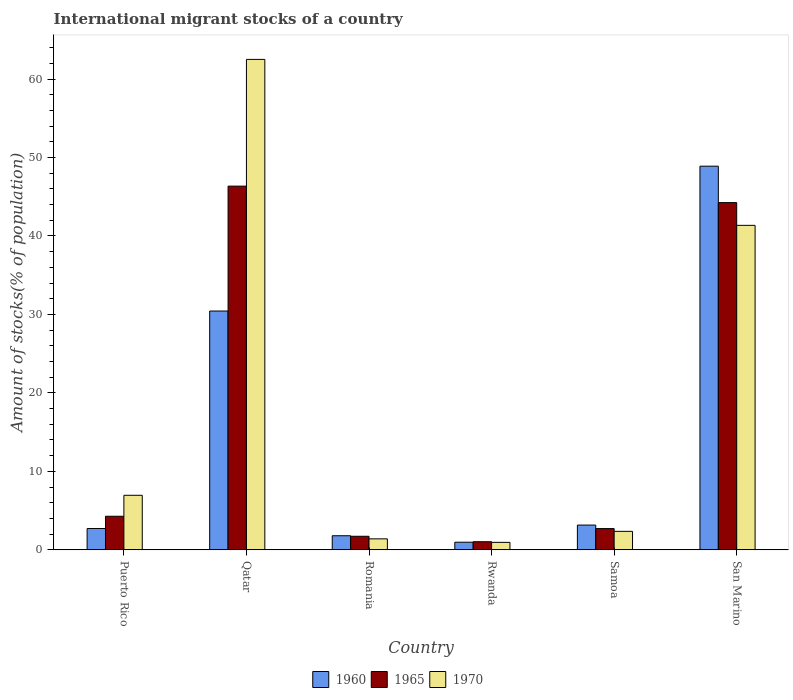How many different coloured bars are there?
Offer a very short reply. 3. Are the number of bars per tick equal to the number of legend labels?
Your response must be concise. Yes. How many bars are there on the 2nd tick from the right?
Your answer should be very brief. 3. What is the label of the 2nd group of bars from the left?
Provide a succinct answer. Qatar. In how many cases, is the number of bars for a given country not equal to the number of legend labels?
Offer a very short reply. 0. What is the amount of stocks in in 1965 in San Marino?
Your answer should be compact. 44.25. Across all countries, what is the maximum amount of stocks in in 1970?
Provide a succinct answer. 62.51. Across all countries, what is the minimum amount of stocks in in 1965?
Give a very brief answer. 1.03. In which country was the amount of stocks in in 1960 maximum?
Your answer should be compact. San Marino. In which country was the amount of stocks in in 1965 minimum?
Offer a very short reply. Rwanda. What is the total amount of stocks in in 1965 in the graph?
Ensure brevity in your answer.  100.36. What is the difference between the amount of stocks in in 1970 in Samoa and that in San Marino?
Keep it short and to the point. -39. What is the difference between the amount of stocks in in 1965 in Puerto Rico and the amount of stocks in in 1960 in Rwanda?
Your answer should be very brief. 3.31. What is the average amount of stocks in in 1965 per country?
Make the answer very short. 16.73. What is the difference between the amount of stocks in of/in 1960 and amount of stocks in of/in 1970 in Puerto Rico?
Your answer should be compact. -4.24. In how many countries, is the amount of stocks in in 1960 greater than 36 %?
Offer a terse response. 1. What is the ratio of the amount of stocks in in 1965 in Puerto Rico to that in Romania?
Give a very brief answer. 2.47. Is the difference between the amount of stocks in in 1960 in Rwanda and San Marino greater than the difference between the amount of stocks in in 1970 in Rwanda and San Marino?
Provide a short and direct response. No. What is the difference between the highest and the second highest amount of stocks in in 1970?
Your answer should be compact. -21.15. What is the difference between the highest and the lowest amount of stocks in in 1960?
Provide a short and direct response. 47.93. In how many countries, is the amount of stocks in in 1965 greater than the average amount of stocks in in 1965 taken over all countries?
Make the answer very short. 2. Is the sum of the amount of stocks in in 1965 in Puerto Rico and Samoa greater than the maximum amount of stocks in in 1970 across all countries?
Offer a terse response. No. Is it the case that in every country, the sum of the amount of stocks in in 1965 and amount of stocks in in 1960 is greater than the amount of stocks in in 1970?
Offer a terse response. Yes. Are all the bars in the graph horizontal?
Provide a succinct answer. No. Does the graph contain any zero values?
Offer a very short reply. No. Does the graph contain grids?
Keep it short and to the point. No. What is the title of the graph?
Make the answer very short. International migrant stocks of a country. Does "2002" appear as one of the legend labels in the graph?
Make the answer very short. No. What is the label or title of the Y-axis?
Give a very brief answer. Amount of stocks(% of population). What is the Amount of stocks(% of population) of 1960 in Puerto Rico?
Your response must be concise. 2.72. What is the Amount of stocks(% of population) in 1965 in Puerto Rico?
Your answer should be very brief. 4.28. What is the Amount of stocks(% of population) in 1970 in Puerto Rico?
Make the answer very short. 6.95. What is the Amount of stocks(% of population) in 1960 in Qatar?
Your response must be concise. 30.44. What is the Amount of stocks(% of population) of 1965 in Qatar?
Offer a very short reply. 46.36. What is the Amount of stocks(% of population) in 1970 in Qatar?
Offer a terse response. 62.51. What is the Amount of stocks(% of population) of 1960 in Romania?
Ensure brevity in your answer.  1.8. What is the Amount of stocks(% of population) of 1965 in Romania?
Your answer should be compact. 1.73. What is the Amount of stocks(% of population) in 1970 in Romania?
Make the answer very short. 1.4. What is the Amount of stocks(% of population) in 1960 in Rwanda?
Offer a terse response. 0.97. What is the Amount of stocks(% of population) of 1965 in Rwanda?
Your answer should be compact. 1.03. What is the Amount of stocks(% of population) in 1970 in Rwanda?
Offer a very short reply. 0.95. What is the Amount of stocks(% of population) of 1960 in Samoa?
Your answer should be compact. 3.16. What is the Amount of stocks(% of population) of 1965 in Samoa?
Provide a succinct answer. 2.71. What is the Amount of stocks(% of population) in 1970 in Samoa?
Offer a terse response. 2.36. What is the Amount of stocks(% of population) in 1960 in San Marino?
Keep it short and to the point. 48.9. What is the Amount of stocks(% of population) in 1965 in San Marino?
Provide a succinct answer. 44.25. What is the Amount of stocks(% of population) in 1970 in San Marino?
Provide a short and direct response. 41.36. Across all countries, what is the maximum Amount of stocks(% of population) of 1960?
Provide a succinct answer. 48.9. Across all countries, what is the maximum Amount of stocks(% of population) of 1965?
Make the answer very short. 46.36. Across all countries, what is the maximum Amount of stocks(% of population) of 1970?
Provide a short and direct response. 62.51. Across all countries, what is the minimum Amount of stocks(% of population) of 1960?
Make the answer very short. 0.97. Across all countries, what is the minimum Amount of stocks(% of population) in 1965?
Your answer should be very brief. 1.03. Across all countries, what is the minimum Amount of stocks(% of population) in 1970?
Offer a very short reply. 0.95. What is the total Amount of stocks(% of population) of 1960 in the graph?
Your response must be concise. 87.98. What is the total Amount of stocks(% of population) in 1965 in the graph?
Keep it short and to the point. 100.36. What is the total Amount of stocks(% of population) in 1970 in the graph?
Your answer should be very brief. 115.53. What is the difference between the Amount of stocks(% of population) of 1960 in Puerto Rico and that in Qatar?
Make the answer very short. -27.72. What is the difference between the Amount of stocks(% of population) in 1965 in Puerto Rico and that in Qatar?
Offer a terse response. -42.07. What is the difference between the Amount of stocks(% of population) of 1970 in Puerto Rico and that in Qatar?
Offer a terse response. -55.56. What is the difference between the Amount of stocks(% of population) in 1960 in Puerto Rico and that in Romania?
Offer a terse response. 0.92. What is the difference between the Amount of stocks(% of population) in 1965 in Puerto Rico and that in Romania?
Your answer should be compact. 2.55. What is the difference between the Amount of stocks(% of population) of 1970 in Puerto Rico and that in Romania?
Ensure brevity in your answer.  5.55. What is the difference between the Amount of stocks(% of population) in 1960 in Puerto Rico and that in Rwanda?
Your answer should be compact. 1.74. What is the difference between the Amount of stocks(% of population) of 1965 in Puerto Rico and that in Rwanda?
Give a very brief answer. 3.25. What is the difference between the Amount of stocks(% of population) in 1970 in Puerto Rico and that in Rwanda?
Offer a terse response. 6. What is the difference between the Amount of stocks(% of population) of 1960 in Puerto Rico and that in Samoa?
Keep it short and to the point. -0.44. What is the difference between the Amount of stocks(% of population) in 1965 in Puerto Rico and that in Samoa?
Offer a very short reply. 1.57. What is the difference between the Amount of stocks(% of population) in 1970 in Puerto Rico and that in Samoa?
Your answer should be very brief. 4.6. What is the difference between the Amount of stocks(% of population) in 1960 in Puerto Rico and that in San Marino?
Provide a short and direct response. -46.18. What is the difference between the Amount of stocks(% of population) in 1965 in Puerto Rico and that in San Marino?
Your response must be concise. -39.97. What is the difference between the Amount of stocks(% of population) in 1970 in Puerto Rico and that in San Marino?
Your response must be concise. -34.4. What is the difference between the Amount of stocks(% of population) of 1960 in Qatar and that in Romania?
Provide a short and direct response. 28.64. What is the difference between the Amount of stocks(% of population) of 1965 in Qatar and that in Romania?
Ensure brevity in your answer.  44.63. What is the difference between the Amount of stocks(% of population) in 1970 in Qatar and that in Romania?
Make the answer very short. 61.11. What is the difference between the Amount of stocks(% of population) of 1960 in Qatar and that in Rwanda?
Offer a very short reply. 29.47. What is the difference between the Amount of stocks(% of population) of 1965 in Qatar and that in Rwanda?
Ensure brevity in your answer.  45.32. What is the difference between the Amount of stocks(% of population) of 1970 in Qatar and that in Rwanda?
Provide a short and direct response. 61.56. What is the difference between the Amount of stocks(% of population) in 1960 in Qatar and that in Samoa?
Ensure brevity in your answer.  27.28. What is the difference between the Amount of stocks(% of population) of 1965 in Qatar and that in Samoa?
Ensure brevity in your answer.  43.65. What is the difference between the Amount of stocks(% of population) of 1970 in Qatar and that in Samoa?
Offer a very short reply. 60.15. What is the difference between the Amount of stocks(% of population) in 1960 in Qatar and that in San Marino?
Give a very brief answer. -18.46. What is the difference between the Amount of stocks(% of population) of 1965 in Qatar and that in San Marino?
Give a very brief answer. 2.1. What is the difference between the Amount of stocks(% of population) in 1970 in Qatar and that in San Marino?
Give a very brief answer. 21.15. What is the difference between the Amount of stocks(% of population) in 1960 in Romania and that in Rwanda?
Ensure brevity in your answer.  0.82. What is the difference between the Amount of stocks(% of population) of 1965 in Romania and that in Rwanda?
Keep it short and to the point. 0.7. What is the difference between the Amount of stocks(% of population) in 1970 in Romania and that in Rwanda?
Provide a short and direct response. 0.45. What is the difference between the Amount of stocks(% of population) of 1960 in Romania and that in Samoa?
Keep it short and to the point. -1.36. What is the difference between the Amount of stocks(% of population) of 1965 in Romania and that in Samoa?
Keep it short and to the point. -0.98. What is the difference between the Amount of stocks(% of population) in 1970 in Romania and that in Samoa?
Offer a terse response. -0.95. What is the difference between the Amount of stocks(% of population) of 1960 in Romania and that in San Marino?
Offer a terse response. -47.1. What is the difference between the Amount of stocks(% of population) in 1965 in Romania and that in San Marino?
Keep it short and to the point. -42.52. What is the difference between the Amount of stocks(% of population) in 1970 in Romania and that in San Marino?
Keep it short and to the point. -39.95. What is the difference between the Amount of stocks(% of population) of 1960 in Rwanda and that in Samoa?
Give a very brief answer. -2.18. What is the difference between the Amount of stocks(% of population) of 1965 in Rwanda and that in Samoa?
Your answer should be very brief. -1.67. What is the difference between the Amount of stocks(% of population) in 1970 in Rwanda and that in Samoa?
Ensure brevity in your answer.  -1.4. What is the difference between the Amount of stocks(% of population) in 1960 in Rwanda and that in San Marino?
Your answer should be compact. -47.93. What is the difference between the Amount of stocks(% of population) of 1965 in Rwanda and that in San Marino?
Give a very brief answer. -43.22. What is the difference between the Amount of stocks(% of population) in 1970 in Rwanda and that in San Marino?
Provide a succinct answer. -40.4. What is the difference between the Amount of stocks(% of population) in 1960 in Samoa and that in San Marino?
Your answer should be very brief. -45.74. What is the difference between the Amount of stocks(% of population) of 1965 in Samoa and that in San Marino?
Your answer should be compact. -41.55. What is the difference between the Amount of stocks(% of population) of 1970 in Samoa and that in San Marino?
Ensure brevity in your answer.  -39. What is the difference between the Amount of stocks(% of population) of 1960 in Puerto Rico and the Amount of stocks(% of population) of 1965 in Qatar?
Offer a terse response. -43.64. What is the difference between the Amount of stocks(% of population) of 1960 in Puerto Rico and the Amount of stocks(% of population) of 1970 in Qatar?
Give a very brief answer. -59.79. What is the difference between the Amount of stocks(% of population) in 1965 in Puerto Rico and the Amount of stocks(% of population) in 1970 in Qatar?
Give a very brief answer. -58.23. What is the difference between the Amount of stocks(% of population) of 1960 in Puerto Rico and the Amount of stocks(% of population) of 1965 in Romania?
Your answer should be very brief. 0.99. What is the difference between the Amount of stocks(% of population) in 1960 in Puerto Rico and the Amount of stocks(% of population) in 1970 in Romania?
Your response must be concise. 1.32. What is the difference between the Amount of stocks(% of population) of 1965 in Puerto Rico and the Amount of stocks(% of population) of 1970 in Romania?
Offer a very short reply. 2.88. What is the difference between the Amount of stocks(% of population) of 1960 in Puerto Rico and the Amount of stocks(% of population) of 1965 in Rwanda?
Offer a very short reply. 1.68. What is the difference between the Amount of stocks(% of population) in 1960 in Puerto Rico and the Amount of stocks(% of population) in 1970 in Rwanda?
Your answer should be very brief. 1.76. What is the difference between the Amount of stocks(% of population) of 1965 in Puerto Rico and the Amount of stocks(% of population) of 1970 in Rwanda?
Offer a very short reply. 3.33. What is the difference between the Amount of stocks(% of population) in 1960 in Puerto Rico and the Amount of stocks(% of population) in 1965 in Samoa?
Provide a succinct answer. 0.01. What is the difference between the Amount of stocks(% of population) in 1960 in Puerto Rico and the Amount of stocks(% of population) in 1970 in Samoa?
Offer a very short reply. 0.36. What is the difference between the Amount of stocks(% of population) of 1965 in Puerto Rico and the Amount of stocks(% of population) of 1970 in Samoa?
Give a very brief answer. 1.92. What is the difference between the Amount of stocks(% of population) of 1960 in Puerto Rico and the Amount of stocks(% of population) of 1965 in San Marino?
Keep it short and to the point. -41.54. What is the difference between the Amount of stocks(% of population) of 1960 in Puerto Rico and the Amount of stocks(% of population) of 1970 in San Marino?
Offer a very short reply. -38.64. What is the difference between the Amount of stocks(% of population) of 1965 in Puerto Rico and the Amount of stocks(% of population) of 1970 in San Marino?
Offer a very short reply. -37.08. What is the difference between the Amount of stocks(% of population) of 1960 in Qatar and the Amount of stocks(% of population) of 1965 in Romania?
Make the answer very short. 28.71. What is the difference between the Amount of stocks(% of population) of 1960 in Qatar and the Amount of stocks(% of population) of 1970 in Romania?
Offer a very short reply. 29.04. What is the difference between the Amount of stocks(% of population) of 1965 in Qatar and the Amount of stocks(% of population) of 1970 in Romania?
Provide a short and direct response. 44.95. What is the difference between the Amount of stocks(% of population) in 1960 in Qatar and the Amount of stocks(% of population) in 1965 in Rwanda?
Make the answer very short. 29.4. What is the difference between the Amount of stocks(% of population) of 1960 in Qatar and the Amount of stocks(% of population) of 1970 in Rwanda?
Give a very brief answer. 29.49. What is the difference between the Amount of stocks(% of population) of 1965 in Qatar and the Amount of stocks(% of population) of 1970 in Rwanda?
Provide a succinct answer. 45.4. What is the difference between the Amount of stocks(% of population) of 1960 in Qatar and the Amount of stocks(% of population) of 1965 in Samoa?
Your answer should be very brief. 27.73. What is the difference between the Amount of stocks(% of population) in 1960 in Qatar and the Amount of stocks(% of population) in 1970 in Samoa?
Your answer should be compact. 28.08. What is the difference between the Amount of stocks(% of population) in 1965 in Qatar and the Amount of stocks(% of population) in 1970 in Samoa?
Your answer should be compact. 44. What is the difference between the Amount of stocks(% of population) in 1960 in Qatar and the Amount of stocks(% of population) in 1965 in San Marino?
Ensure brevity in your answer.  -13.82. What is the difference between the Amount of stocks(% of population) in 1960 in Qatar and the Amount of stocks(% of population) in 1970 in San Marino?
Keep it short and to the point. -10.92. What is the difference between the Amount of stocks(% of population) of 1965 in Qatar and the Amount of stocks(% of population) of 1970 in San Marino?
Make the answer very short. 5. What is the difference between the Amount of stocks(% of population) in 1960 in Romania and the Amount of stocks(% of population) in 1965 in Rwanda?
Provide a short and direct response. 0.76. What is the difference between the Amount of stocks(% of population) of 1960 in Romania and the Amount of stocks(% of population) of 1970 in Rwanda?
Provide a succinct answer. 0.85. What is the difference between the Amount of stocks(% of population) in 1965 in Romania and the Amount of stocks(% of population) in 1970 in Rwanda?
Make the answer very short. 0.78. What is the difference between the Amount of stocks(% of population) in 1960 in Romania and the Amount of stocks(% of population) in 1965 in Samoa?
Your answer should be compact. -0.91. What is the difference between the Amount of stocks(% of population) of 1960 in Romania and the Amount of stocks(% of population) of 1970 in Samoa?
Ensure brevity in your answer.  -0.56. What is the difference between the Amount of stocks(% of population) in 1965 in Romania and the Amount of stocks(% of population) in 1970 in Samoa?
Ensure brevity in your answer.  -0.63. What is the difference between the Amount of stocks(% of population) in 1960 in Romania and the Amount of stocks(% of population) in 1965 in San Marino?
Offer a very short reply. -42.46. What is the difference between the Amount of stocks(% of population) in 1960 in Romania and the Amount of stocks(% of population) in 1970 in San Marino?
Keep it short and to the point. -39.56. What is the difference between the Amount of stocks(% of population) in 1965 in Romania and the Amount of stocks(% of population) in 1970 in San Marino?
Keep it short and to the point. -39.63. What is the difference between the Amount of stocks(% of population) in 1960 in Rwanda and the Amount of stocks(% of population) in 1965 in Samoa?
Your answer should be compact. -1.74. What is the difference between the Amount of stocks(% of population) of 1960 in Rwanda and the Amount of stocks(% of population) of 1970 in Samoa?
Provide a short and direct response. -1.38. What is the difference between the Amount of stocks(% of population) of 1965 in Rwanda and the Amount of stocks(% of population) of 1970 in Samoa?
Offer a very short reply. -1.32. What is the difference between the Amount of stocks(% of population) of 1960 in Rwanda and the Amount of stocks(% of population) of 1965 in San Marino?
Provide a succinct answer. -43.28. What is the difference between the Amount of stocks(% of population) of 1960 in Rwanda and the Amount of stocks(% of population) of 1970 in San Marino?
Your answer should be compact. -40.38. What is the difference between the Amount of stocks(% of population) in 1965 in Rwanda and the Amount of stocks(% of population) in 1970 in San Marino?
Keep it short and to the point. -40.32. What is the difference between the Amount of stocks(% of population) in 1960 in Samoa and the Amount of stocks(% of population) in 1965 in San Marino?
Provide a succinct answer. -41.1. What is the difference between the Amount of stocks(% of population) of 1960 in Samoa and the Amount of stocks(% of population) of 1970 in San Marino?
Offer a very short reply. -38.2. What is the difference between the Amount of stocks(% of population) in 1965 in Samoa and the Amount of stocks(% of population) in 1970 in San Marino?
Offer a terse response. -38.65. What is the average Amount of stocks(% of population) of 1960 per country?
Your answer should be very brief. 14.66. What is the average Amount of stocks(% of population) of 1965 per country?
Your response must be concise. 16.73. What is the average Amount of stocks(% of population) in 1970 per country?
Offer a very short reply. 19.25. What is the difference between the Amount of stocks(% of population) of 1960 and Amount of stocks(% of population) of 1965 in Puerto Rico?
Provide a succinct answer. -1.56. What is the difference between the Amount of stocks(% of population) in 1960 and Amount of stocks(% of population) in 1970 in Puerto Rico?
Make the answer very short. -4.24. What is the difference between the Amount of stocks(% of population) of 1965 and Amount of stocks(% of population) of 1970 in Puerto Rico?
Offer a terse response. -2.67. What is the difference between the Amount of stocks(% of population) of 1960 and Amount of stocks(% of population) of 1965 in Qatar?
Your response must be concise. -15.92. What is the difference between the Amount of stocks(% of population) in 1960 and Amount of stocks(% of population) in 1970 in Qatar?
Keep it short and to the point. -32.07. What is the difference between the Amount of stocks(% of population) in 1965 and Amount of stocks(% of population) in 1970 in Qatar?
Offer a terse response. -16.15. What is the difference between the Amount of stocks(% of population) in 1960 and Amount of stocks(% of population) in 1965 in Romania?
Your answer should be very brief. 0.07. What is the difference between the Amount of stocks(% of population) of 1960 and Amount of stocks(% of population) of 1970 in Romania?
Provide a succinct answer. 0.4. What is the difference between the Amount of stocks(% of population) of 1965 and Amount of stocks(% of population) of 1970 in Romania?
Keep it short and to the point. 0.33. What is the difference between the Amount of stocks(% of population) in 1960 and Amount of stocks(% of population) in 1965 in Rwanda?
Give a very brief answer. -0.06. What is the difference between the Amount of stocks(% of population) of 1960 and Amount of stocks(% of population) of 1970 in Rwanda?
Provide a short and direct response. 0.02. What is the difference between the Amount of stocks(% of population) of 1965 and Amount of stocks(% of population) of 1970 in Rwanda?
Ensure brevity in your answer.  0.08. What is the difference between the Amount of stocks(% of population) in 1960 and Amount of stocks(% of population) in 1965 in Samoa?
Offer a very short reply. 0.45. What is the difference between the Amount of stocks(% of population) in 1960 and Amount of stocks(% of population) in 1970 in Samoa?
Keep it short and to the point. 0.8. What is the difference between the Amount of stocks(% of population) in 1965 and Amount of stocks(% of population) in 1970 in Samoa?
Make the answer very short. 0.35. What is the difference between the Amount of stocks(% of population) of 1960 and Amount of stocks(% of population) of 1965 in San Marino?
Make the answer very short. 4.64. What is the difference between the Amount of stocks(% of population) in 1960 and Amount of stocks(% of population) in 1970 in San Marino?
Make the answer very short. 7.54. What is the difference between the Amount of stocks(% of population) of 1965 and Amount of stocks(% of population) of 1970 in San Marino?
Your answer should be very brief. 2.9. What is the ratio of the Amount of stocks(% of population) of 1960 in Puerto Rico to that in Qatar?
Offer a terse response. 0.09. What is the ratio of the Amount of stocks(% of population) in 1965 in Puerto Rico to that in Qatar?
Offer a terse response. 0.09. What is the ratio of the Amount of stocks(% of population) of 1970 in Puerto Rico to that in Qatar?
Your answer should be very brief. 0.11. What is the ratio of the Amount of stocks(% of population) of 1960 in Puerto Rico to that in Romania?
Keep it short and to the point. 1.51. What is the ratio of the Amount of stocks(% of population) of 1965 in Puerto Rico to that in Romania?
Ensure brevity in your answer.  2.47. What is the ratio of the Amount of stocks(% of population) in 1970 in Puerto Rico to that in Romania?
Provide a succinct answer. 4.96. What is the ratio of the Amount of stocks(% of population) of 1960 in Puerto Rico to that in Rwanda?
Your answer should be compact. 2.79. What is the ratio of the Amount of stocks(% of population) in 1965 in Puerto Rico to that in Rwanda?
Offer a very short reply. 4.14. What is the ratio of the Amount of stocks(% of population) of 1970 in Puerto Rico to that in Rwanda?
Your answer should be compact. 7.3. What is the ratio of the Amount of stocks(% of population) in 1960 in Puerto Rico to that in Samoa?
Offer a terse response. 0.86. What is the ratio of the Amount of stocks(% of population) in 1965 in Puerto Rico to that in Samoa?
Give a very brief answer. 1.58. What is the ratio of the Amount of stocks(% of population) in 1970 in Puerto Rico to that in Samoa?
Provide a succinct answer. 2.95. What is the ratio of the Amount of stocks(% of population) in 1960 in Puerto Rico to that in San Marino?
Your answer should be very brief. 0.06. What is the ratio of the Amount of stocks(% of population) in 1965 in Puerto Rico to that in San Marino?
Your answer should be very brief. 0.1. What is the ratio of the Amount of stocks(% of population) of 1970 in Puerto Rico to that in San Marino?
Provide a succinct answer. 0.17. What is the ratio of the Amount of stocks(% of population) in 1960 in Qatar to that in Romania?
Your answer should be very brief. 16.93. What is the ratio of the Amount of stocks(% of population) in 1965 in Qatar to that in Romania?
Offer a very short reply. 26.8. What is the ratio of the Amount of stocks(% of population) in 1970 in Qatar to that in Romania?
Your answer should be very brief. 44.6. What is the ratio of the Amount of stocks(% of population) in 1960 in Qatar to that in Rwanda?
Your answer should be compact. 31.3. What is the ratio of the Amount of stocks(% of population) in 1965 in Qatar to that in Rwanda?
Offer a terse response. 44.81. What is the ratio of the Amount of stocks(% of population) in 1970 in Qatar to that in Rwanda?
Ensure brevity in your answer.  65.63. What is the ratio of the Amount of stocks(% of population) in 1960 in Qatar to that in Samoa?
Your answer should be very brief. 9.64. What is the ratio of the Amount of stocks(% of population) in 1965 in Qatar to that in Samoa?
Keep it short and to the point. 17.11. What is the ratio of the Amount of stocks(% of population) in 1970 in Qatar to that in Samoa?
Your answer should be compact. 26.53. What is the ratio of the Amount of stocks(% of population) of 1960 in Qatar to that in San Marino?
Keep it short and to the point. 0.62. What is the ratio of the Amount of stocks(% of population) in 1965 in Qatar to that in San Marino?
Provide a succinct answer. 1.05. What is the ratio of the Amount of stocks(% of population) in 1970 in Qatar to that in San Marino?
Provide a short and direct response. 1.51. What is the ratio of the Amount of stocks(% of population) of 1960 in Romania to that in Rwanda?
Offer a very short reply. 1.85. What is the ratio of the Amount of stocks(% of population) in 1965 in Romania to that in Rwanda?
Ensure brevity in your answer.  1.67. What is the ratio of the Amount of stocks(% of population) of 1970 in Romania to that in Rwanda?
Your response must be concise. 1.47. What is the ratio of the Amount of stocks(% of population) of 1960 in Romania to that in Samoa?
Give a very brief answer. 0.57. What is the ratio of the Amount of stocks(% of population) of 1965 in Romania to that in Samoa?
Make the answer very short. 0.64. What is the ratio of the Amount of stocks(% of population) in 1970 in Romania to that in Samoa?
Your answer should be very brief. 0.59. What is the ratio of the Amount of stocks(% of population) in 1960 in Romania to that in San Marino?
Your response must be concise. 0.04. What is the ratio of the Amount of stocks(% of population) in 1965 in Romania to that in San Marino?
Keep it short and to the point. 0.04. What is the ratio of the Amount of stocks(% of population) of 1970 in Romania to that in San Marino?
Your response must be concise. 0.03. What is the ratio of the Amount of stocks(% of population) of 1960 in Rwanda to that in Samoa?
Your answer should be very brief. 0.31. What is the ratio of the Amount of stocks(% of population) of 1965 in Rwanda to that in Samoa?
Offer a very short reply. 0.38. What is the ratio of the Amount of stocks(% of population) of 1970 in Rwanda to that in Samoa?
Your answer should be compact. 0.4. What is the ratio of the Amount of stocks(% of population) of 1960 in Rwanda to that in San Marino?
Offer a terse response. 0.02. What is the ratio of the Amount of stocks(% of population) of 1965 in Rwanda to that in San Marino?
Keep it short and to the point. 0.02. What is the ratio of the Amount of stocks(% of population) of 1970 in Rwanda to that in San Marino?
Ensure brevity in your answer.  0.02. What is the ratio of the Amount of stocks(% of population) in 1960 in Samoa to that in San Marino?
Your answer should be compact. 0.06. What is the ratio of the Amount of stocks(% of population) in 1965 in Samoa to that in San Marino?
Make the answer very short. 0.06. What is the ratio of the Amount of stocks(% of population) in 1970 in Samoa to that in San Marino?
Keep it short and to the point. 0.06. What is the difference between the highest and the second highest Amount of stocks(% of population) of 1960?
Give a very brief answer. 18.46. What is the difference between the highest and the second highest Amount of stocks(% of population) of 1965?
Your answer should be compact. 2.1. What is the difference between the highest and the second highest Amount of stocks(% of population) of 1970?
Give a very brief answer. 21.15. What is the difference between the highest and the lowest Amount of stocks(% of population) of 1960?
Provide a short and direct response. 47.93. What is the difference between the highest and the lowest Amount of stocks(% of population) of 1965?
Give a very brief answer. 45.32. What is the difference between the highest and the lowest Amount of stocks(% of population) of 1970?
Provide a succinct answer. 61.56. 